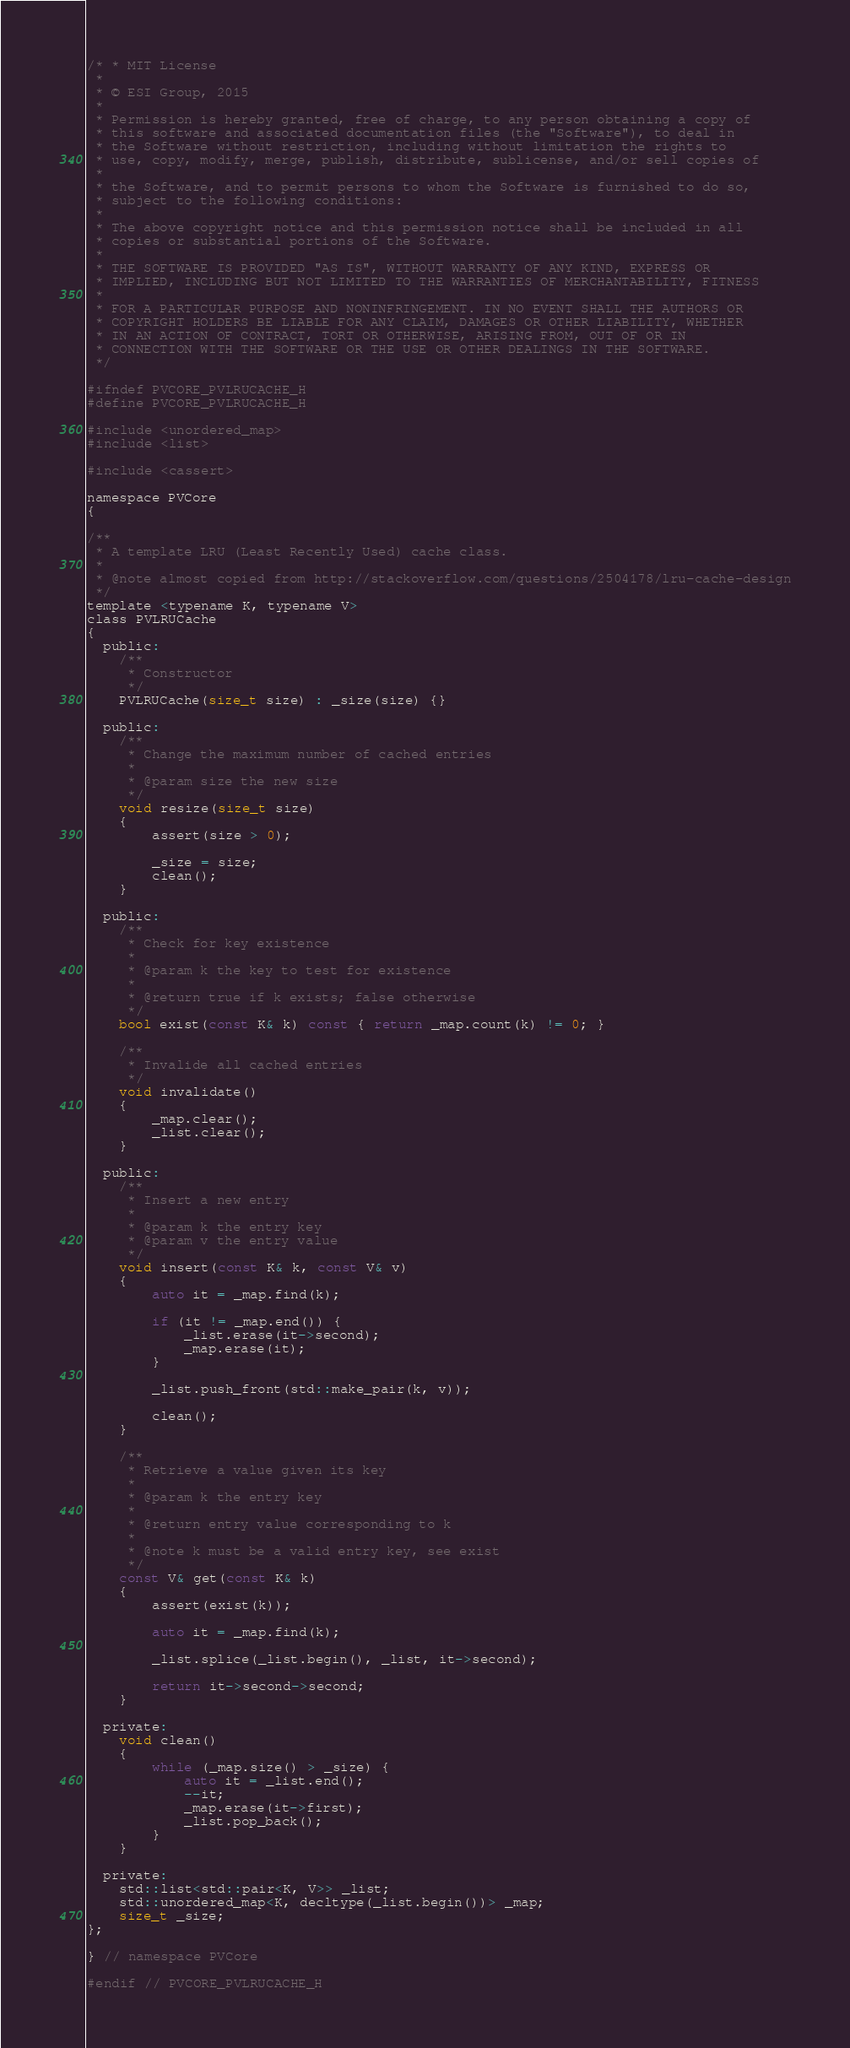Convert code to text. <code><loc_0><loc_0><loc_500><loc_500><_C_>/* * MIT License
 *
 * © ESI Group, 2015
 *
 * Permission is hereby granted, free of charge, to any person obtaining a copy of
 * this software and associated documentation files (the "Software"), to deal in
 * the Software without restriction, including without limitation the rights to
 * use, copy, modify, merge, publish, distribute, sublicense, and/or sell copies of
 *
 * the Software, and to permit persons to whom the Software is furnished to do so,
 * subject to the following conditions:
 *
 * The above copyright notice and this permission notice shall be included in all
 * copies or substantial portions of the Software.
 *
 * THE SOFTWARE IS PROVIDED "AS IS", WITHOUT WARRANTY OF ANY KIND, EXPRESS OR
 * IMPLIED, INCLUDING BUT NOT LIMITED TO THE WARRANTIES OF MERCHANTABILITY, FITNESS
 *
 * FOR A PARTICULAR PURPOSE AND NONINFRINGEMENT. IN NO EVENT SHALL THE AUTHORS OR
 * COPYRIGHT HOLDERS BE LIABLE FOR ANY CLAIM, DAMAGES OR OTHER LIABILITY, WHETHER
 * IN AN ACTION OF CONTRACT, TORT OR OTHERWISE, ARISING FROM, OUT OF OR IN
 * CONNECTION WITH THE SOFTWARE OR THE USE OR OTHER DEALINGS IN THE SOFTWARE.
 */

#ifndef PVCORE_PVLRUCACHE_H
#define PVCORE_PVLRUCACHE_H

#include <unordered_map>
#include <list>

#include <cassert>

namespace PVCore
{

/**
 * A template LRU (Least Recently Used) cache class.
 *
 * @note almost copied from http://stackoverflow.com/questions/2504178/lru-cache-design
 */
template <typename K, typename V>
class PVLRUCache
{
  public:
	/**
	 * Constructor
	 */
	PVLRUCache(size_t size) : _size(size) {}

  public:
	/**
	 * Change the maximum number of cached entries
	 *
	 * @param size the new size
	 */
	void resize(size_t size)
	{
		assert(size > 0);

		_size = size;
		clean();
	}

  public:
	/**
	 * Check for key existence
	 *
	 * @param k the key to test for existence
	 *
	 * @return true if k exists; false otherwise
	 */
	bool exist(const K& k) const { return _map.count(k) != 0; }

	/**
	 * Invalide all cached entries
	 */
	void invalidate()
	{
		_map.clear();
		_list.clear();
	}

  public:
	/**
	 * Insert a new entry
	 *
	 * @param k the entry key
	 * @param v the entry value
	 */
	void insert(const K& k, const V& v)
	{
		auto it = _map.find(k);

		if (it != _map.end()) {
			_list.erase(it->second);
			_map.erase(it);
		}

		_list.push_front(std::make_pair(k, v));

		clean();
	}

	/**
	 * Retrieve a value given its key
	 *
	 * @param k the entry key
	 *
	 * @return entry value corresponding to k
	 *
	 * @note k must be a valid entry key, see exist
	 */
	const V& get(const K& k)
	{
		assert(exist(k));

		auto it = _map.find(k);

		_list.splice(_list.begin(), _list, it->second);

		return it->second->second;
	}

  private:
	void clean()
	{
		while (_map.size() > _size) {
			auto it = _list.end();
			--it;
			_map.erase(it->first);
			_list.pop_back();
		}
	}

  private:
	std::list<std::pair<K, V>> _list;
	std::unordered_map<K, decltype(_list.begin())> _map;
	size_t _size;
};

} // namespace PVCore

#endif // PVCORE_PVLRUCACHE_H
</code> 